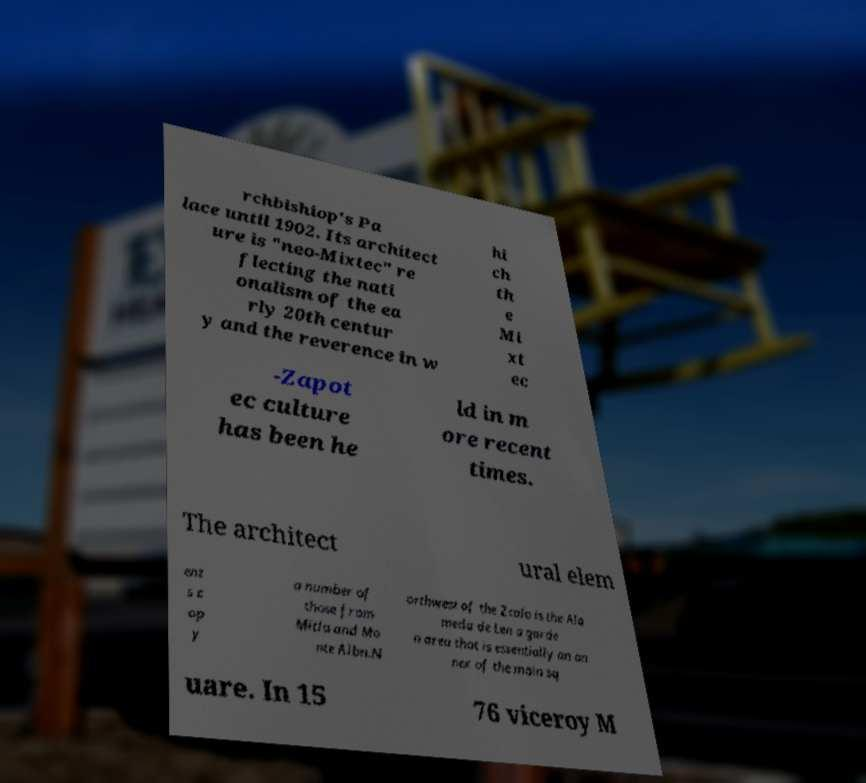Could you extract and type out the text from this image? rchbishiop's Pa lace until 1902. Its architect ure is "neo-Mixtec" re flecting the nati onalism of the ea rly 20th centur y and the reverence in w hi ch th e Mi xt ec -Zapot ec culture has been he ld in m ore recent times. The architect ural elem ent s c op y a number of those from Mitla and Mo nte Albn.N orthwest of the Zcalo is the Ala meda de Len a garde n area that is essentially an an nex of the main sq uare. In 15 76 viceroy M 